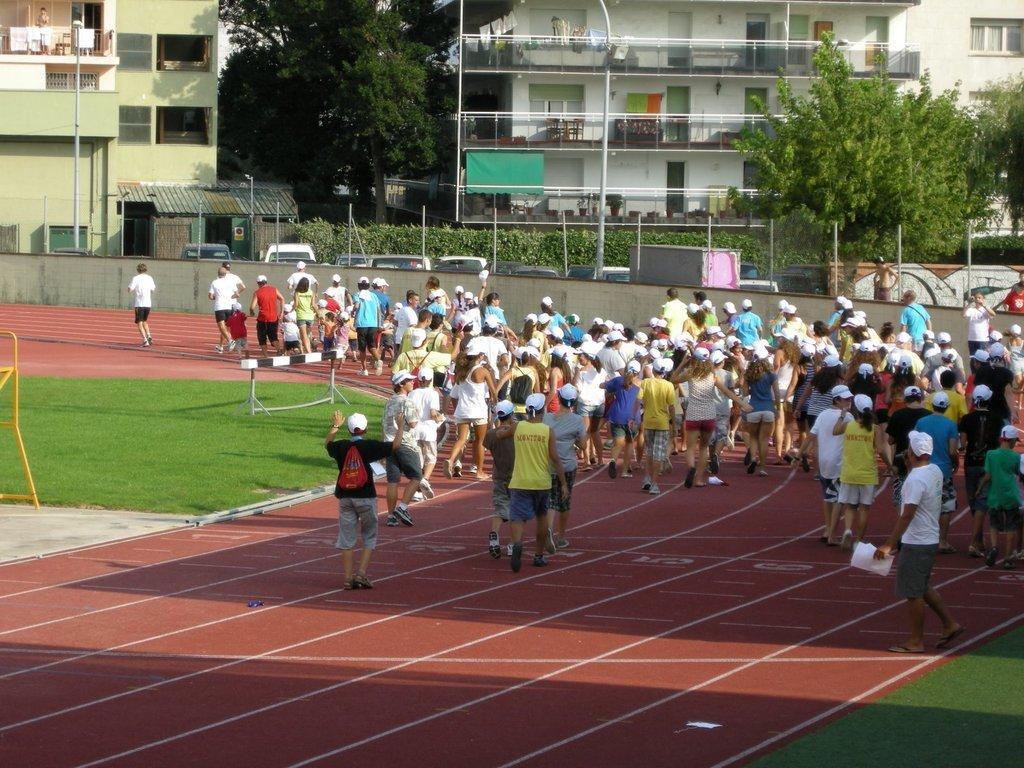Can you describe this image briefly? In this image there are a group of people who are walking,at the bottom there is some grass and ground and in the background there are some houses, trees, poles, plants and some vehicles. 